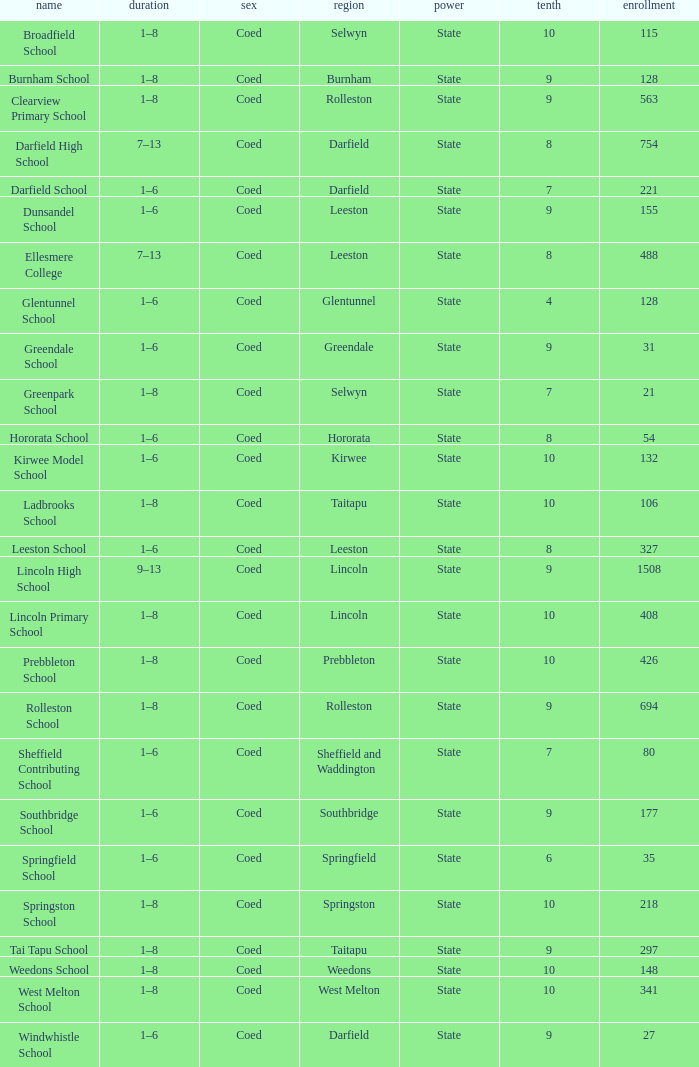What is the name with a Decile less than 10, and a Roll of 297? Tai Tapu School. 